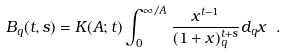Convert formula to latex. <formula><loc_0><loc_0><loc_500><loc_500>\ B _ { q } ( t , s ) = K ( A ; t ) \int _ { 0 } ^ { \infty / A } \frac { x ^ { t - 1 } } { ( 1 + x ) _ { q } ^ { t + s } } d _ { q } x \ .</formula> 